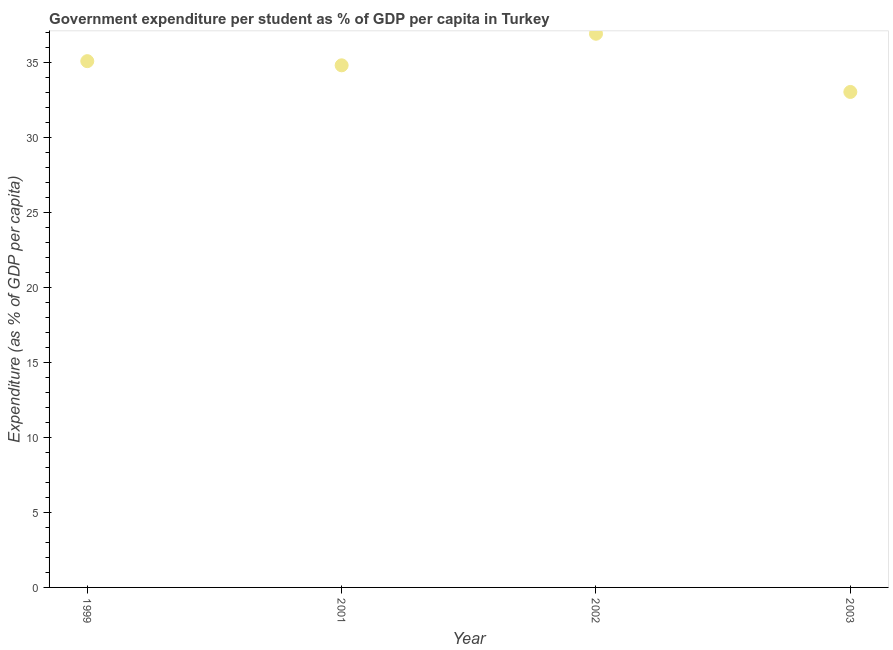What is the government expenditure per student in 1999?
Keep it short and to the point. 35.06. Across all years, what is the maximum government expenditure per student?
Offer a terse response. 36.89. Across all years, what is the minimum government expenditure per student?
Keep it short and to the point. 33.01. In which year was the government expenditure per student minimum?
Offer a very short reply. 2003. What is the sum of the government expenditure per student?
Give a very brief answer. 139.74. What is the difference between the government expenditure per student in 2002 and 2003?
Keep it short and to the point. 3.88. What is the average government expenditure per student per year?
Offer a terse response. 34.93. What is the median government expenditure per student?
Offer a very short reply. 34.92. In how many years, is the government expenditure per student greater than 9 %?
Keep it short and to the point. 4. Do a majority of the years between 2003 and 2002 (inclusive) have government expenditure per student greater than 36 %?
Give a very brief answer. No. What is the ratio of the government expenditure per student in 2001 to that in 2002?
Make the answer very short. 0.94. Is the government expenditure per student in 2001 less than that in 2003?
Offer a very short reply. No. Is the difference between the government expenditure per student in 1999 and 2001 greater than the difference between any two years?
Keep it short and to the point. No. What is the difference between the highest and the second highest government expenditure per student?
Your answer should be compact. 1.83. What is the difference between the highest and the lowest government expenditure per student?
Your answer should be compact. 3.88. Does the government expenditure per student monotonically increase over the years?
Give a very brief answer. No. How many dotlines are there?
Ensure brevity in your answer.  1. How many years are there in the graph?
Ensure brevity in your answer.  4. Are the values on the major ticks of Y-axis written in scientific E-notation?
Your response must be concise. No. What is the title of the graph?
Ensure brevity in your answer.  Government expenditure per student as % of GDP per capita in Turkey. What is the label or title of the Y-axis?
Give a very brief answer. Expenditure (as % of GDP per capita). What is the Expenditure (as % of GDP per capita) in 1999?
Keep it short and to the point. 35.06. What is the Expenditure (as % of GDP per capita) in 2001?
Your answer should be very brief. 34.78. What is the Expenditure (as % of GDP per capita) in 2002?
Keep it short and to the point. 36.89. What is the Expenditure (as % of GDP per capita) in 2003?
Your answer should be compact. 33.01. What is the difference between the Expenditure (as % of GDP per capita) in 1999 and 2001?
Give a very brief answer. 0.28. What is the difference between the Expenditure (as % of GDP per capita) in 1999 and 2002?
Keep it short and to the point. -1.83. What is the difference between the Expenditure (as % of GDP per capita) in 1999 and 2003?
Provide a short and direct response. 2.05. What is the difference between the Expenditure (as % of GDP per capita) in 2001 and 2002?
Give a very brief answer. -2.1. What is the difference between the Expenditure (as % of GDP per capita) in 2001 and 2003?
Make the answer very short. 1.77. What is the difference between the Expenditure (as % of GDP per capita) in 2002 and 2003?
Provide a short and direct response. 3.88. What is the ratio of the Expenditure (as % of GDP per capita) in 1999 to that in 2001?
Offer a terse response. 1.01. What is the ratio of the Expenditure (as % of GDP per capita) in 1999 to that in 2003?
Ensure brevity in your answer.  1.06. What is the ratio of the Expenditure (as % of GDP per capita) in 2001 to that in 2002?
Provide a succinct answer. 0.94. What is the ratio of the Expenditure (as % of GDP per capita) in 2001 to that in 2003?
Offer a terse response. 1.05. What is the ratio of the Expenditure (as % of GDP per capita) in 2002 to that in 2003?
Give a very brief answer. 1.12. 